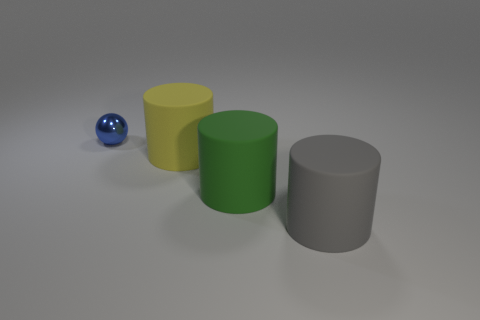Subtract all big gray cylinders. How many cylinders are left? 2 Add 3 tiny cyan blocks. How many objects exist? 7 Subtract all cylinders. How many objects are left? 1 Add 4 yellow cylinders. How many yellow cylinders are left? 5 Add 4 metal blocks. How many metal blocks exist? 4 Subtract 0 gray cubes. How many objects are left? 4 Subtract all blue things. Subtract all tiny blue shiny things. How many objects are left? 2 